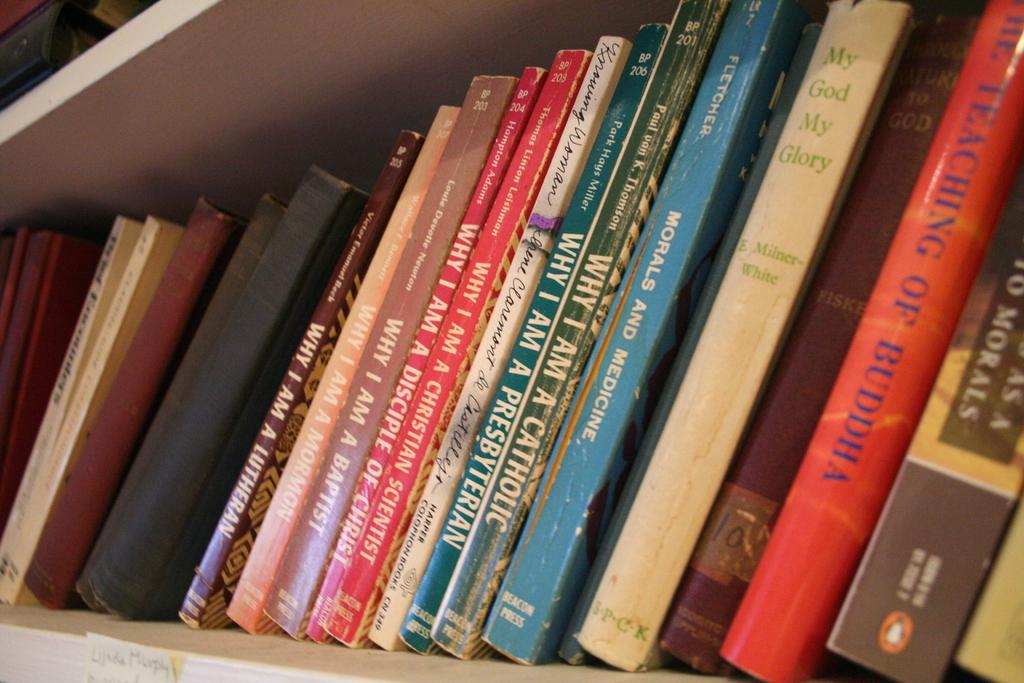Provide a one-sentence caption for the provided image. a stack of books with one of them titled 'my god my glory' in green. 